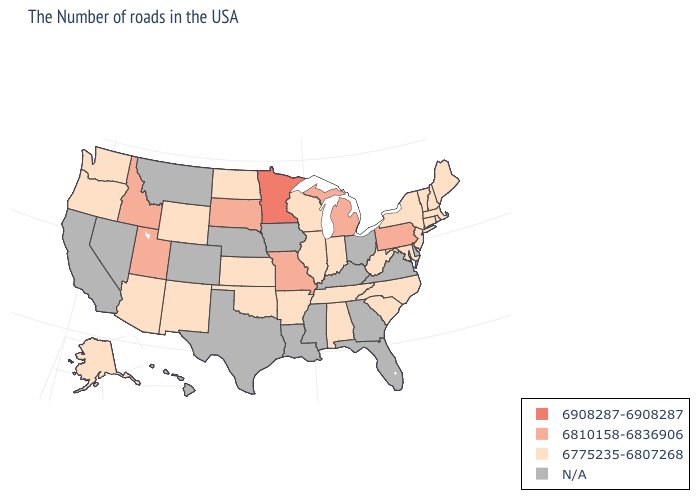Name the states that have a value in the range 6810158-6836906?
Be succinct. Pennsylvania, Michigan, Missouri, South Dakota, Utah, Idaho. What is the value of North Dakota?
Give a very brief answer. 6775235-6807268. What is the value of Virginia?
Be succinct. N/A. What is the lowest value in states that border New Mexico?
Quick response, please. 6775235-6807268. What is the lowest value in states that border Tennessee?
Keep it brief. 6775235-6807268. Among the states that border Arkansas , which have the lowest value?
Answer briefly. Tennessee, Oklahoma. Name the states that have a value in the range 6810158-6836906?
Quick response, please. Pennsylvania, Michigan, Missouri, South Dakota, Utah, Idaho. What is the value of Wisconsin?
Short answer required. 6775235-6807268. Name the states that have a value in the range 6810158-6836906?
Keep it brief. Pennsylvania, Michigan, Missouri, South Dakota, Utah, Idaho. What is the value of Illinois?
Concise answer only. 6775235-6807268. What is the highest value in states that border Indiana?
Short answer required. 6810158-6836906. Does New Hampshire have the highest value in the Northeast?
Quick response, please. No. How many symbols are there in the legend?
Be succinct. 4. Does Washington have the lowest value in the West?
Give a very brief answer. Yes. 